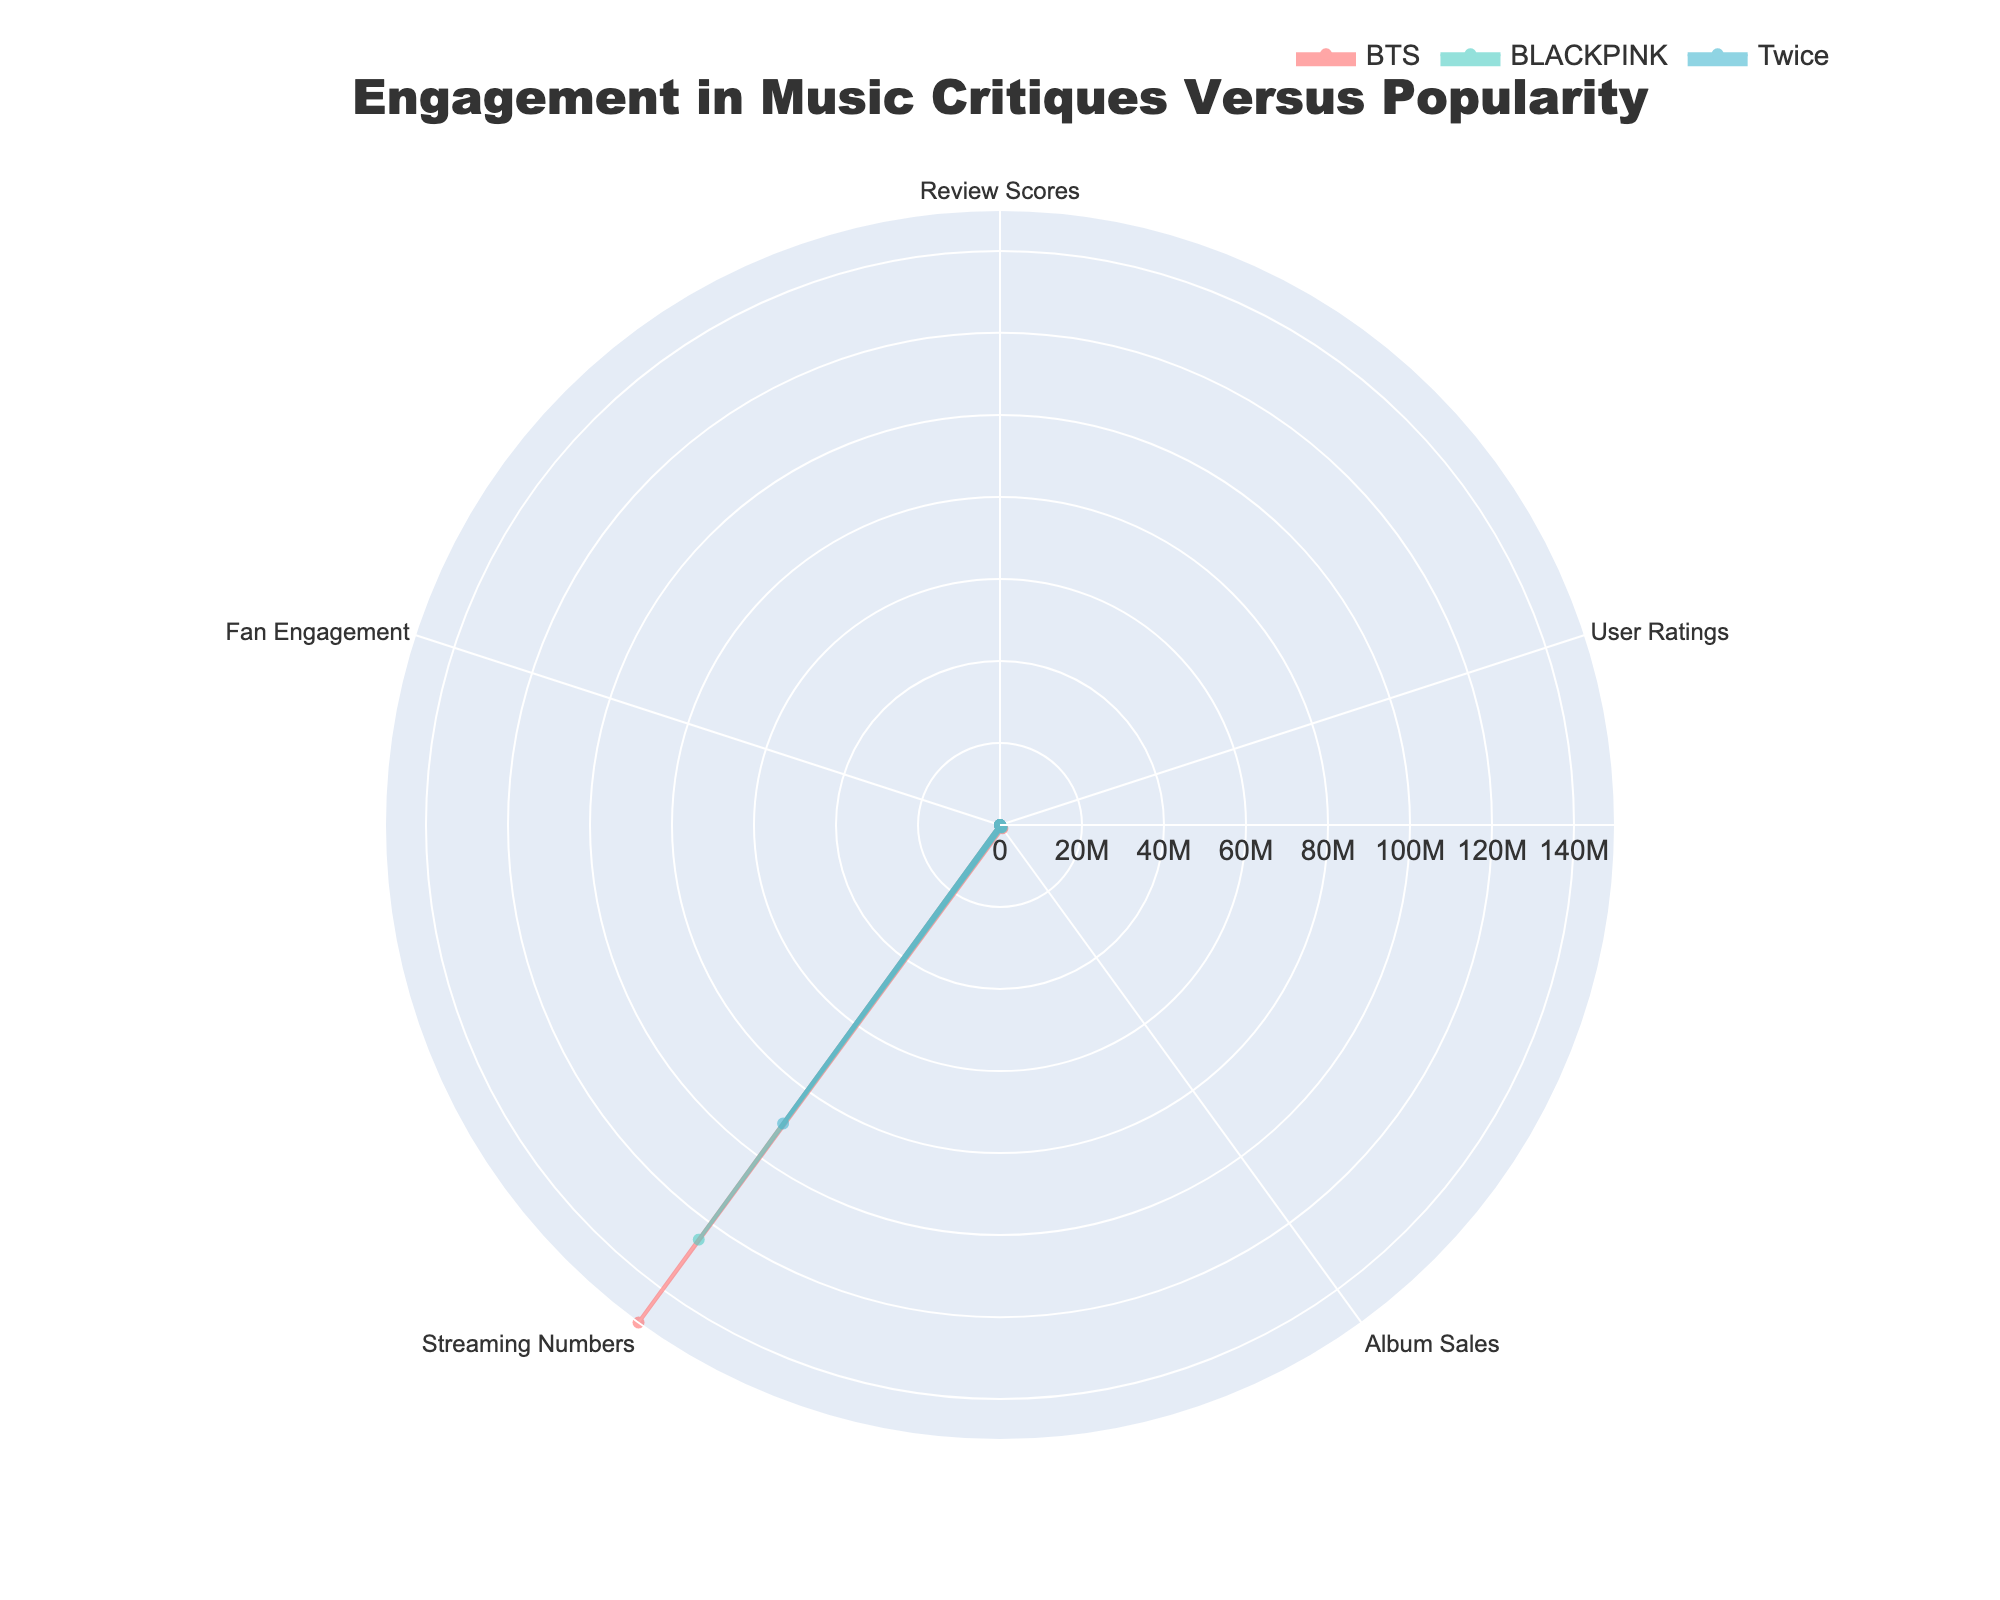How many categories are displayed in the radar chart? Count the categories displayed in the chart: Review Scores, User Ratings, Album Sales, Streaming Numbers, and Fan Engagement.
Answer: 5 Which group has the highest Fan Engagement? Observe the Fan Engagement values for each group. BTS has 98, which is the highest among the groups compared.
Answer: BTS What is the average Review Score of the groups displayed? Sum up the Review Scores of BTS (90), BLACKPINK (85), and Twice (80): 90 + 85 + 80 = 255. Then, divide by 3 (number of groups): 255 / 3 = 85.
Answer: 85 Which group shows the least difference between Review Scores and User Ratings? Calculate the differences: BTS (95-90 = 5), BLACKPINK (93-85 = 8), and Twice (88-80 = 8). BTS has the smallest difference of 5.
Answer: BTS Which two groups have the closest Album Sales? Compare the Album Sales values: BTS (1,000,000) and BLACKPINK (750,000) vs. BLACKPINK and Twice (600,000). The smallest difference is between BLACKPINK and Twice (750,000 - 600,000 = 150,000).
Answer: BLACKPINK and Twice What is the total Streaming Numbers for all displayed groups? Sum the Streaming Numbers of BTS (150,000,000), BLACKPINK (125,000,000), and Twice (90,000,000): 150,000,000 + 125,000,000 + 90,000,000 = 365,000,000.
Answer: 365,000,000 Which group has the lowest value in any category? Identify the lowest values in each category among the groups: BTS (Review Scores 90), BLACKPINK (User Ratings 85), and Twice (Streaming Numbers 90,000,000). The lowest value (75) is NCT 127's Review Scores.
Answer: NCT 127 How do BTS’s User Ratings compare with BLACKPINK’s? Compare BTS's User Ratings (95) with BLACKPINK's (93). BTS has higher User Ratings.
Answer: BTS Which group has the most balanced scores across all categories? Examine the variability of the values for each group. BTS has values close to each other (90, 95, 1,000,000, 150,000,000, 98), indicating the most balanced scores.
Answer: BTS 